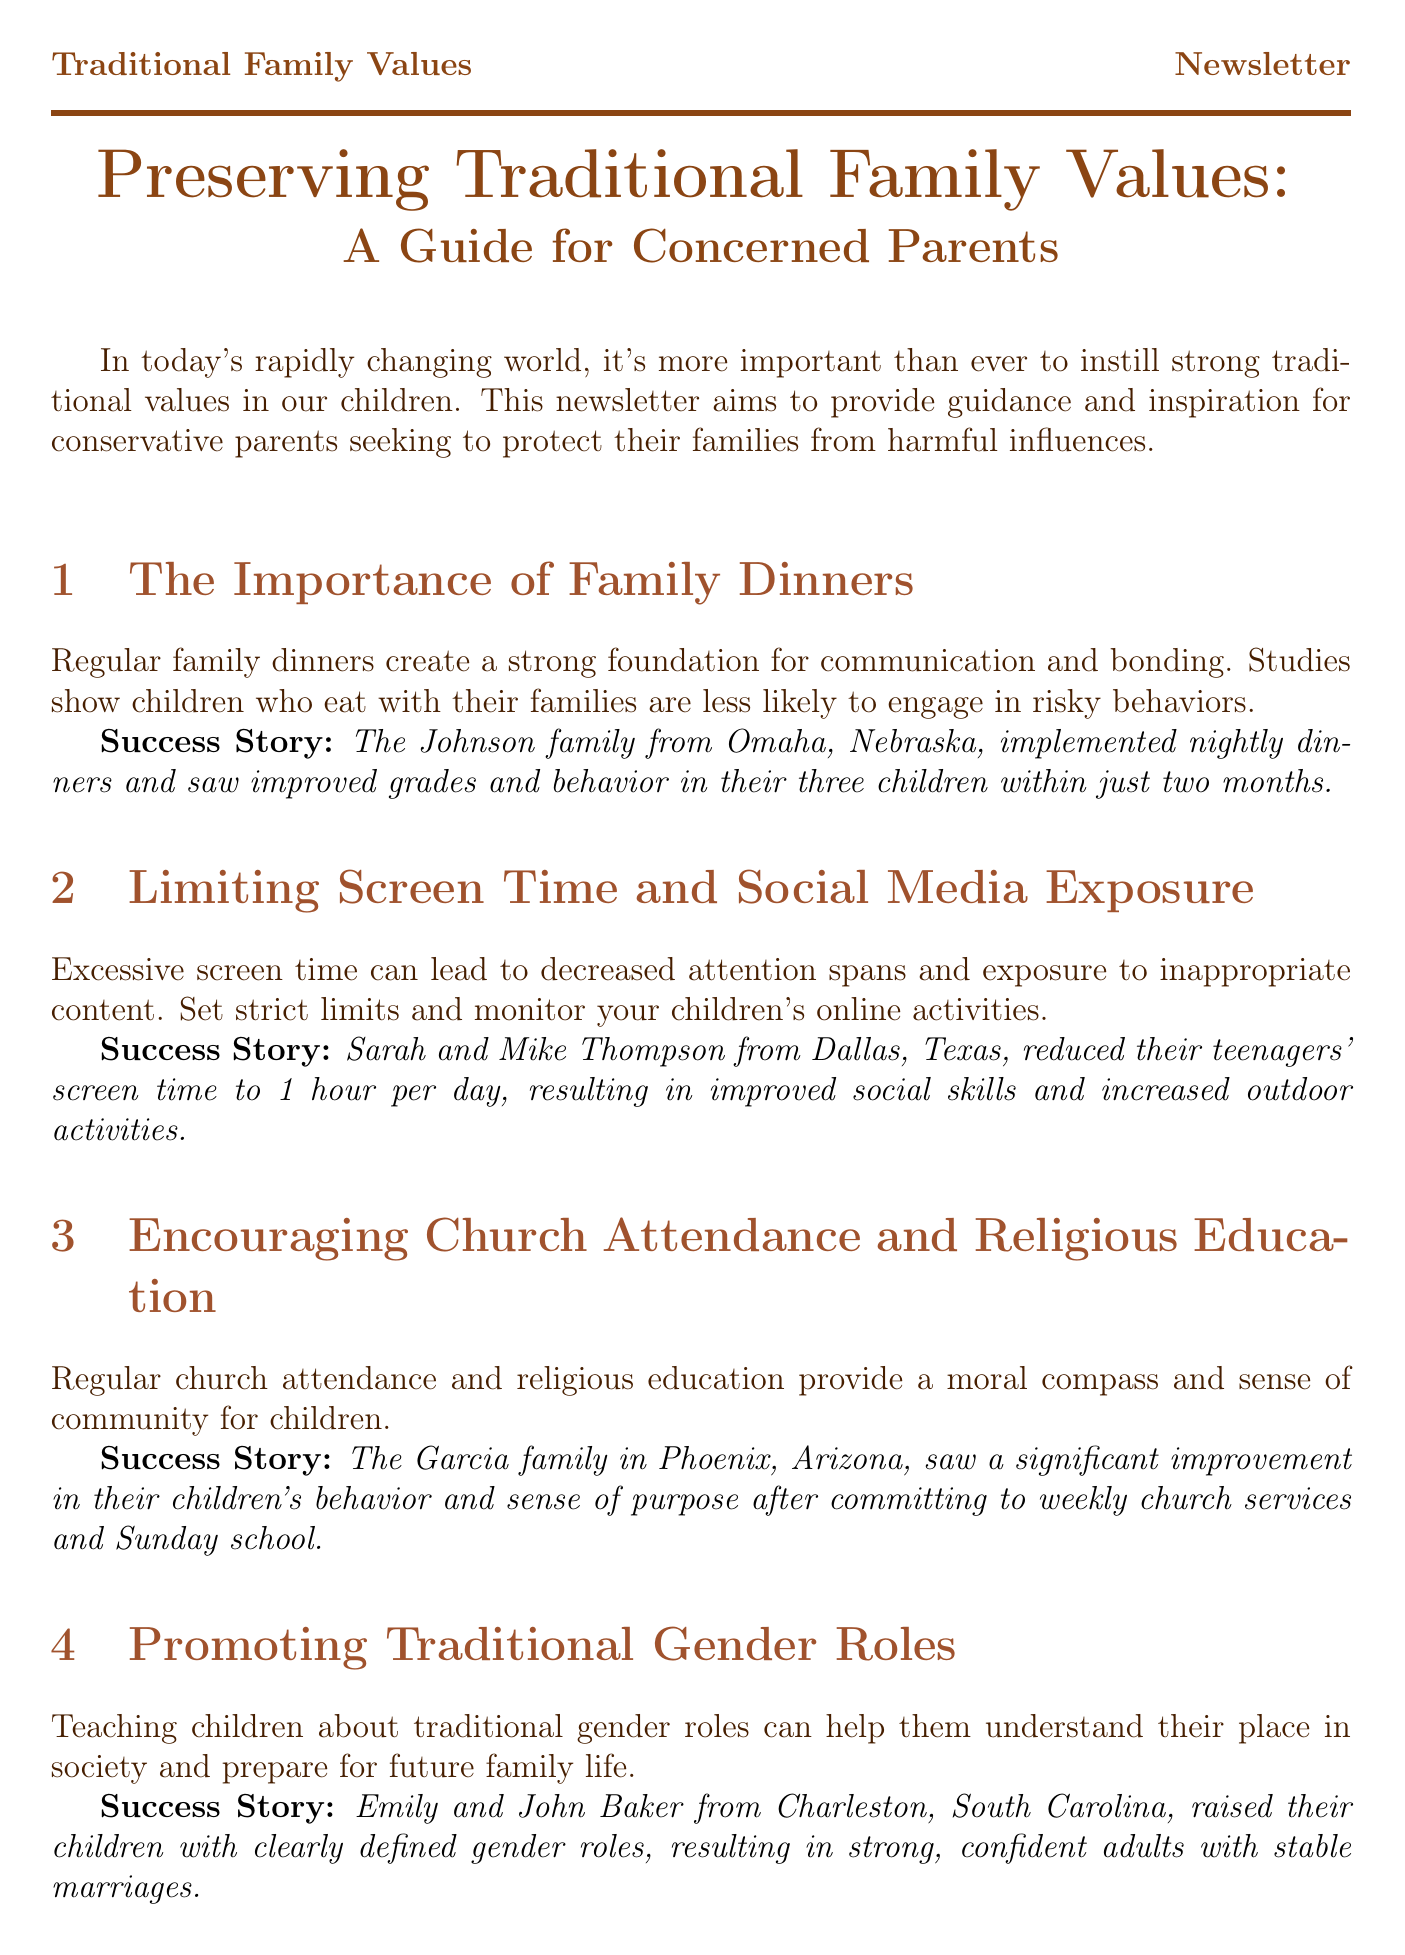What is the title of the newsletter? The title of the newsletter is prominently indicated at the beginning of the document.
Answer: Preserving Traditional Family Values: A Guide for Concerned Parents What is one benefit of regular family dinners mentioned? The document states that family dinners create a foundation for communication and that children are less likely to engage in risky behaviors.
Answer: Strong foundation for communication How many children does the Johnson family have? The success story of the Johnson family mentions the number of children they have.
Answer: Three children What action did Sarah and Mike Thompson take regarding screen time? The document highlights the specific change the Thompson family made to manage their teenagers' screen time.
Answer: Reduced to 1 hour per day Which family committed to weekly church services? The document provides a success story featuring a family that made a commitment related to church attendance.
Answer: Garcia family What is the recommended reading title by Dr. James Dobson? The additional resources section lists specific recommended books, including one by Dr. James Dobson.
Answer: The Traditional Family Values Bible What common theme is promoted regarding children's roles? The newsletter emphasizes a specific teaching approach regarding children's understanding of society.
Answer: Traditional gender roles What was the result of the chore system implemented by the Miller family? The document describes the outcome of the chore system in terms of the children's development and performance.
Answer: Increased independence and better academic performance 